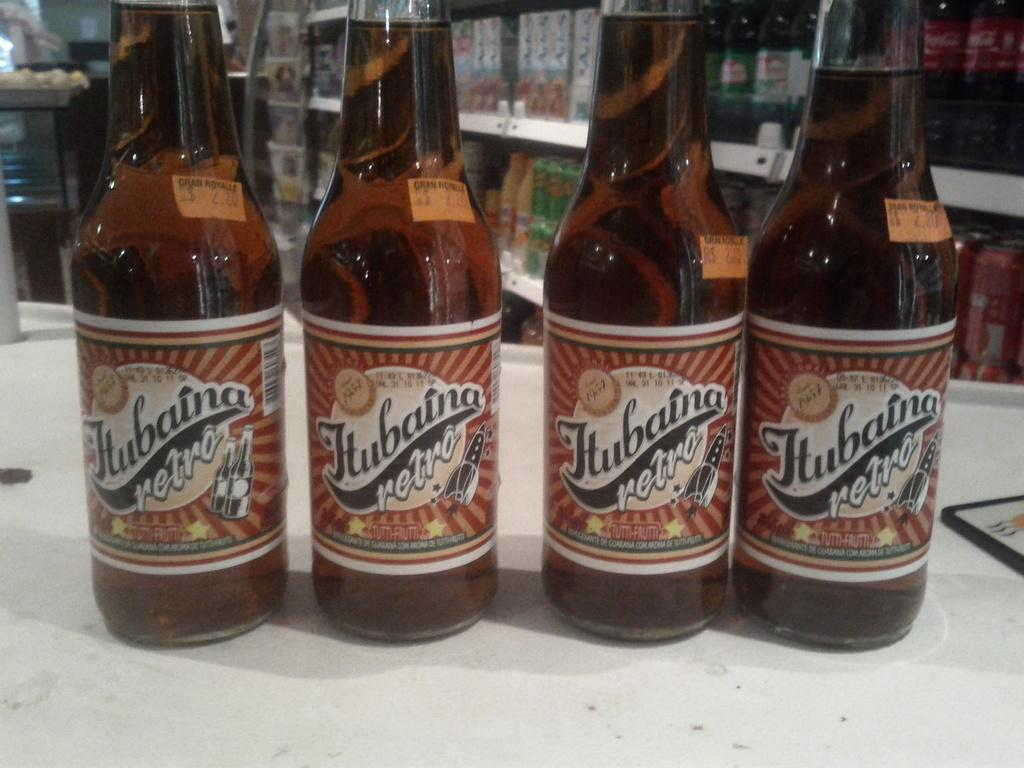<image>
Summarize the visual content of the image. Four bottles of retro beer sit side by side on a counter. 